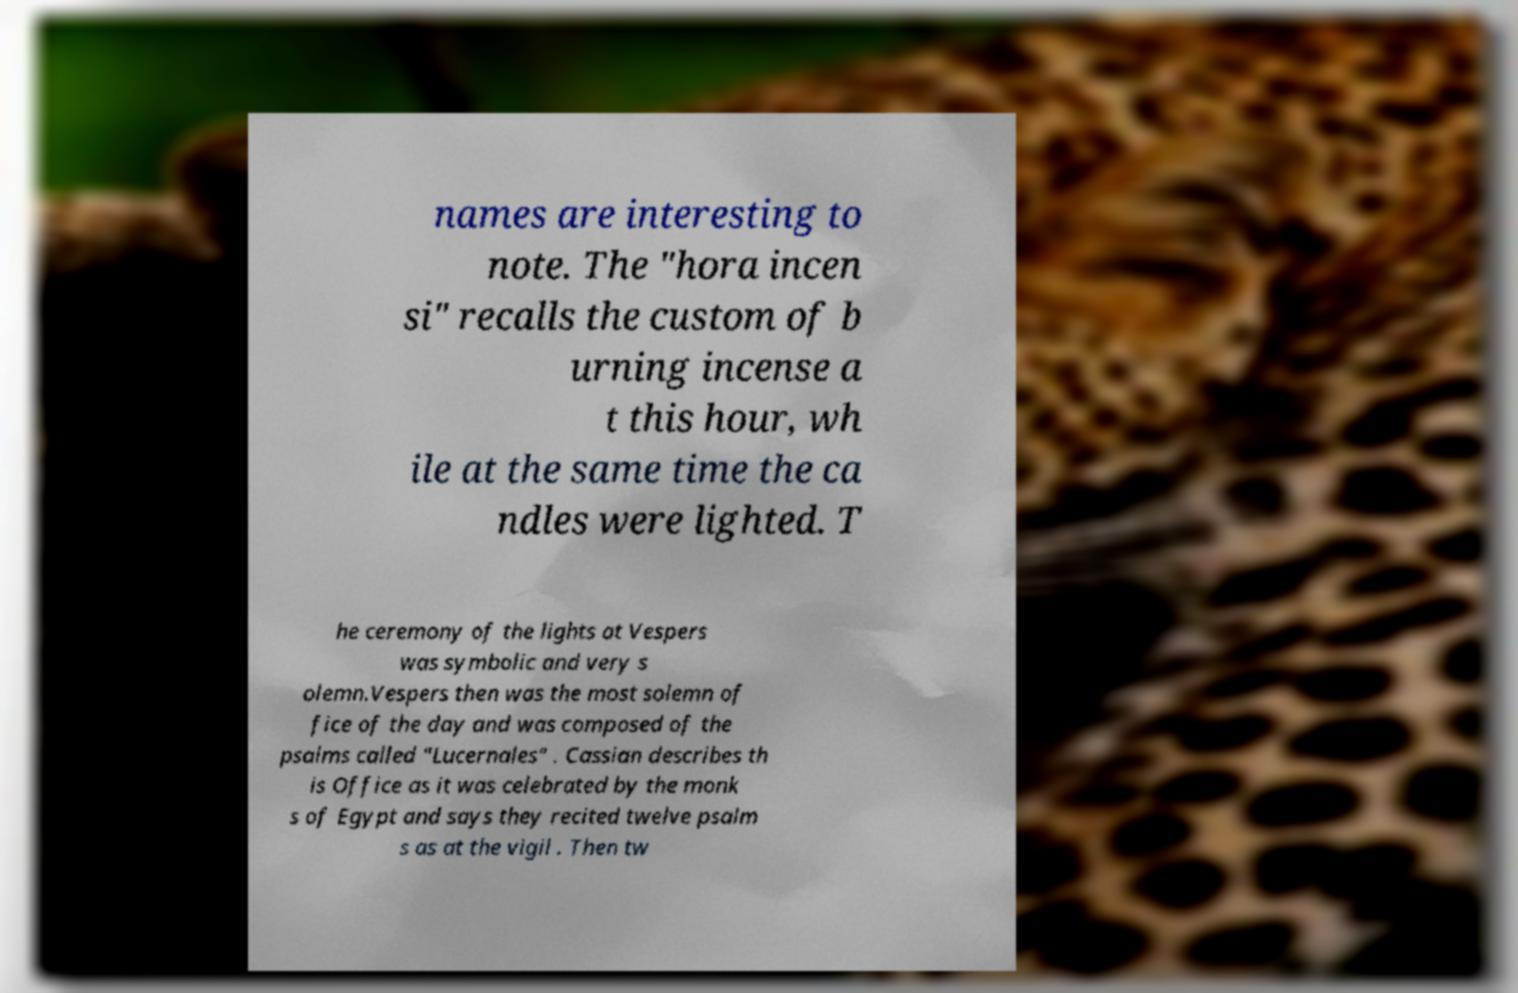I need the written content from this picture converted into text. Can you do that? names are interesting to note. The "hora incen si" recalls the custom of b urning incense a t this hour, wh ile at the same time the ca ndles were lighted. T he ceremony of the lights at Vespers was symbolic and very s olemn.Vespers then was the most solemn of fice of the day and was composed of the psalms called "Lucernales" . Cassian describes th is Office as it was celebrated by the monk s of Egypt and says they recited twelve psalm s as at the vigil . Then tw 